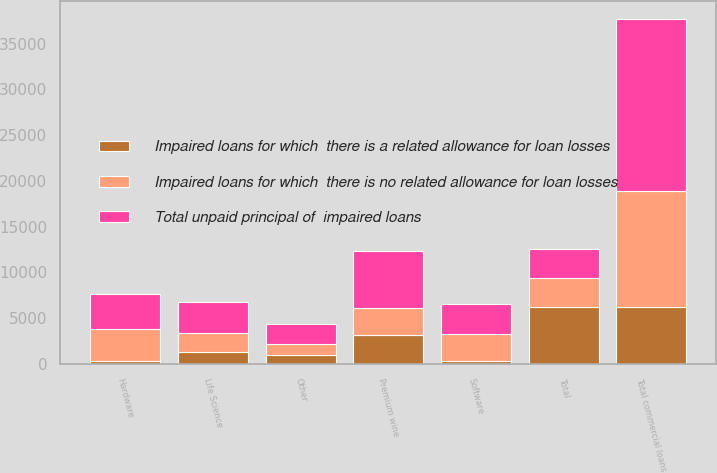Convert chart to OTSL. <chart><loc_0><loc_0><loc_500><loc_500><stacked_bar_chart><ecel><fcel>Software<fcel>Hardware<fcel>Life Science<fcel>Premium wine<fcel>Other<fcel>Total commercial loans<fcel>Total<nl><fcel>Impaired loans for which  there is no related allowance for loan losses<fcel>2958<fcel>3517<fcel>2050<fcel>2995<fcel>1158<fcel>12678<fcel>3167<nl><fcel>Impaired loans for which  there is a related allowance for loan losses<fcel>334<fcel>307<fcel>1362<fcel>3167<fcel>1019<fcel>6189<fcel>6189<nl><fcel>Total unpaid principal of  impaired loans<fcel>3292<fcel>3824<fcel>3412<fcel>6162<fcel>2177<fcel>18867<fcel>3167<nl></chart> 